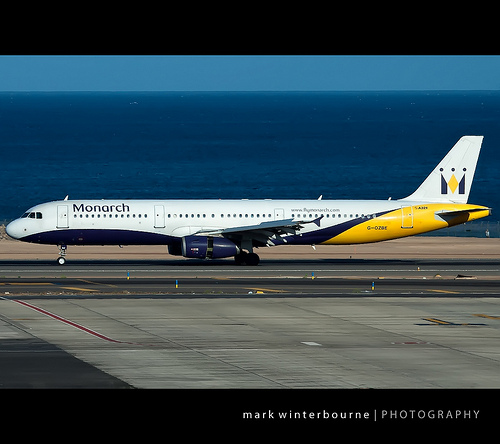Please provide the bounding box coordinate of the region this sentence describes: nose of jet. The nose of the jet is located within the bounding box coordinates [0.0, 0.46, 0.1, 0.54]. 